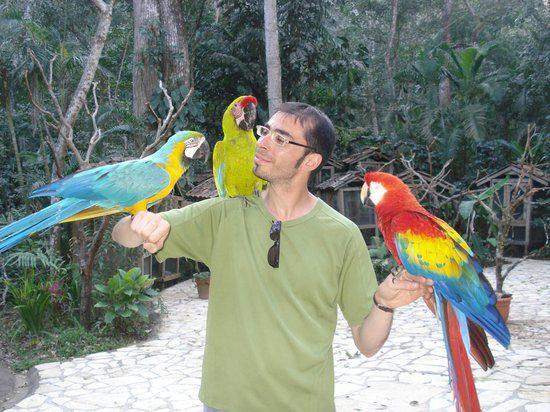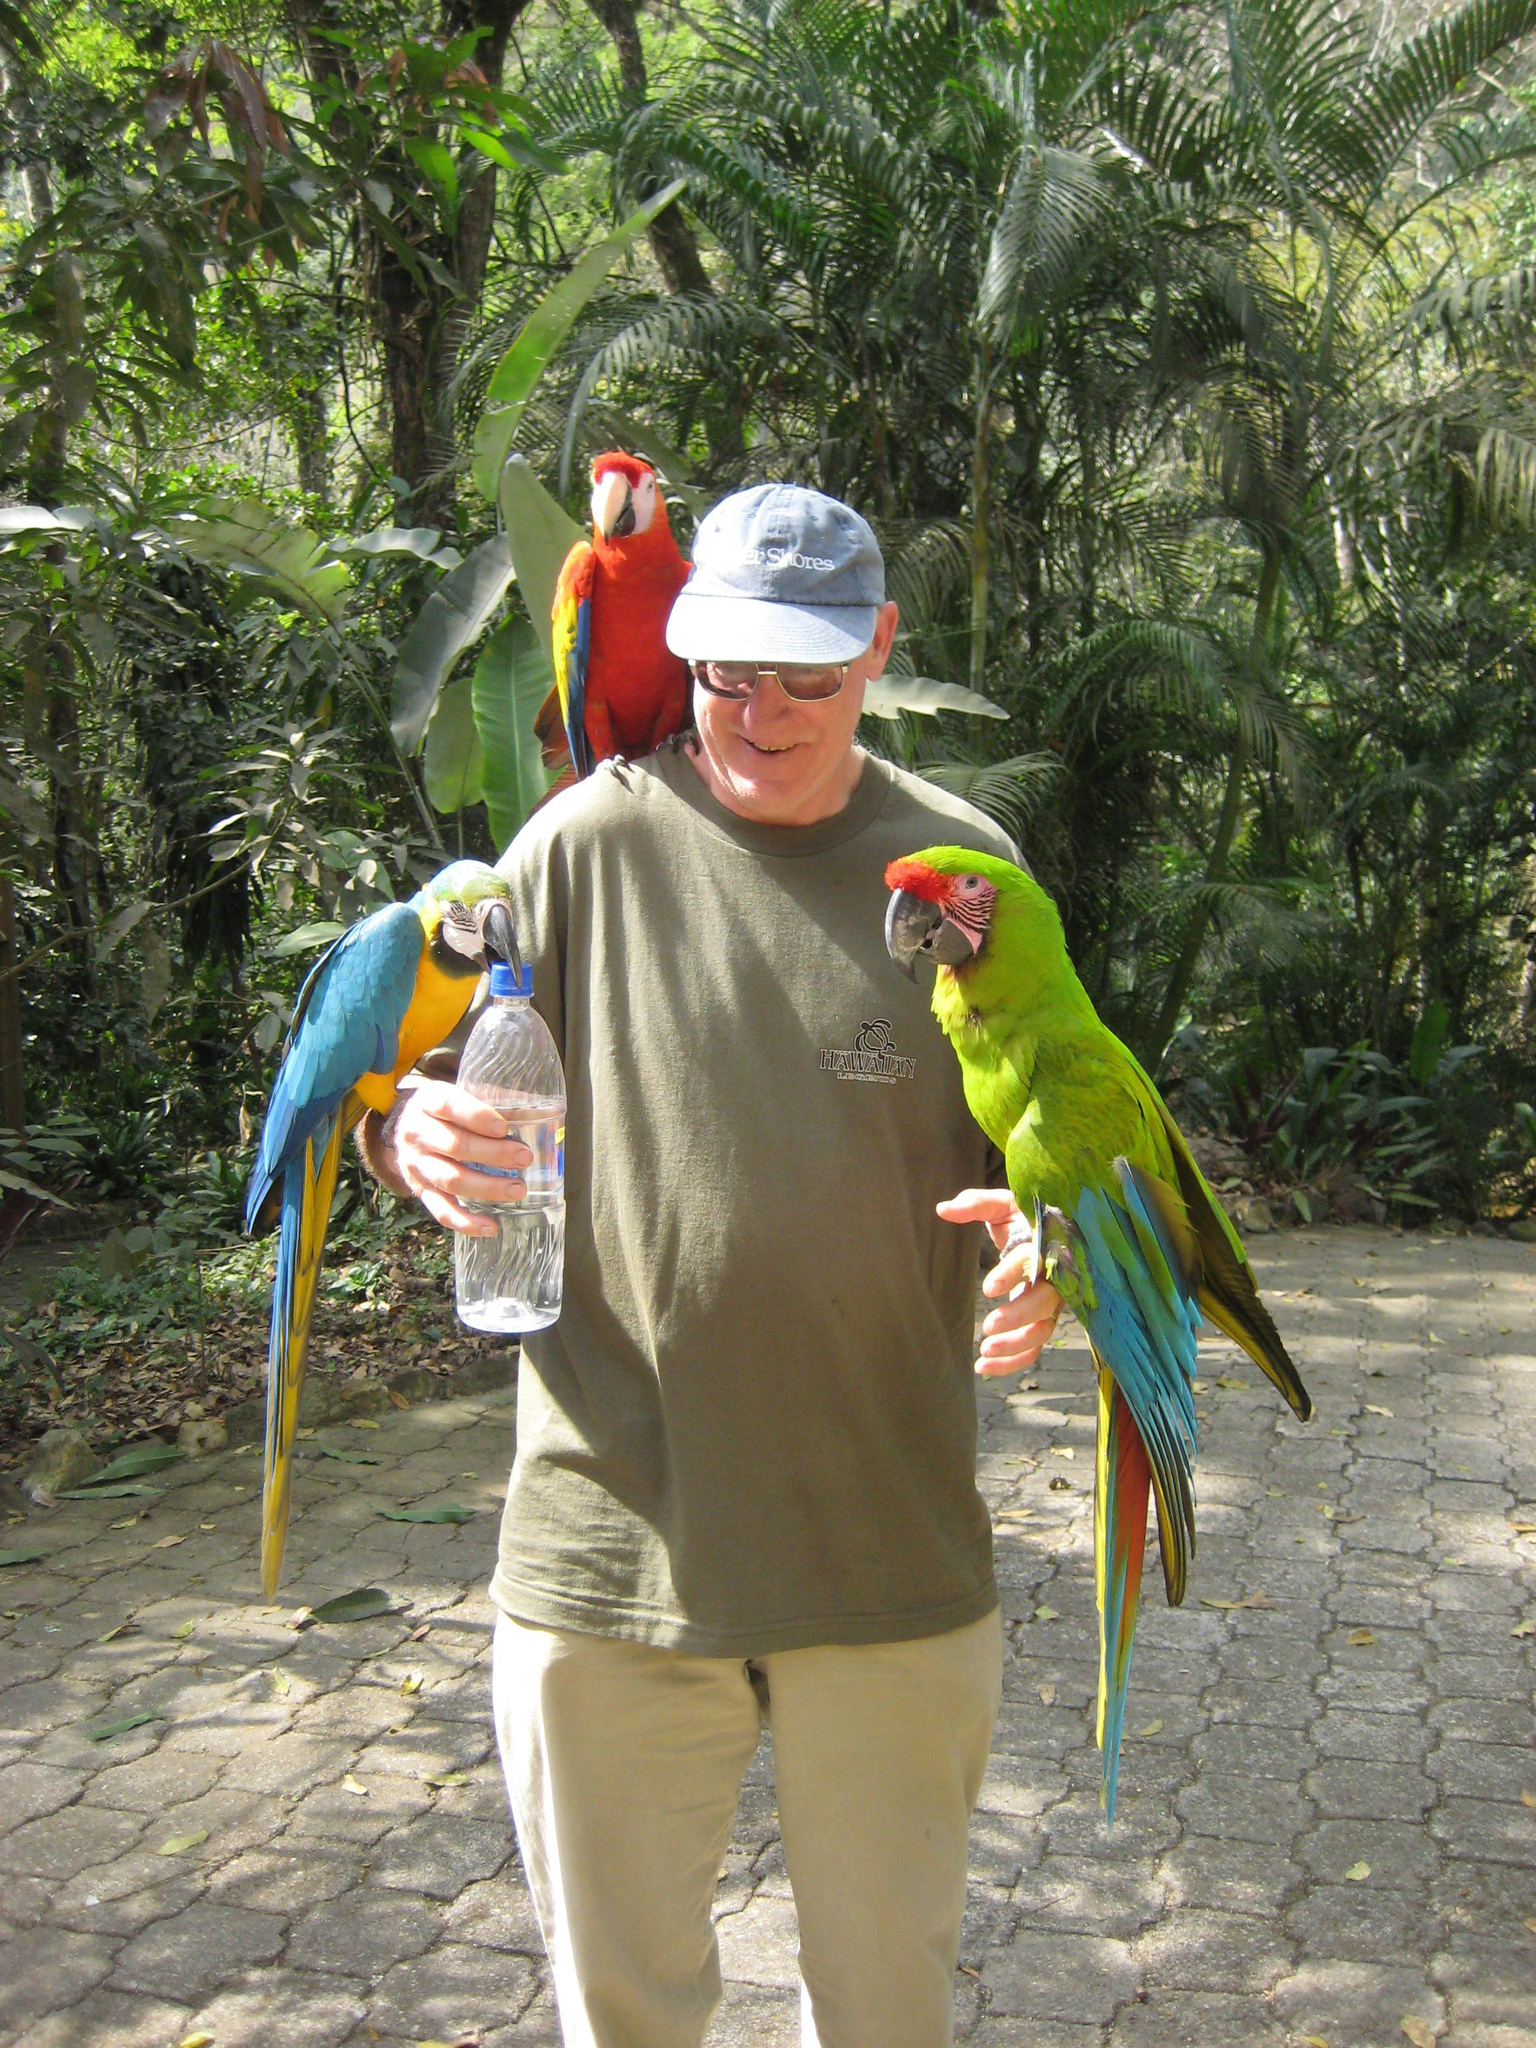The first image is the image on the left, the second image is the image on the right. For the images displayed, is the sentence "There are three birds sitting on a person,  one on each arm and one on their shoulder." factually correct? Answer yes or no. Yes. The first image is the image on the left, the second image is the image on the right. Examine the images to the left and right. Is the description "On both pictures, parrots can be seen perched on a human, one on each arm and one on a shoulder." accurate? Answer yes or no. Yes. 